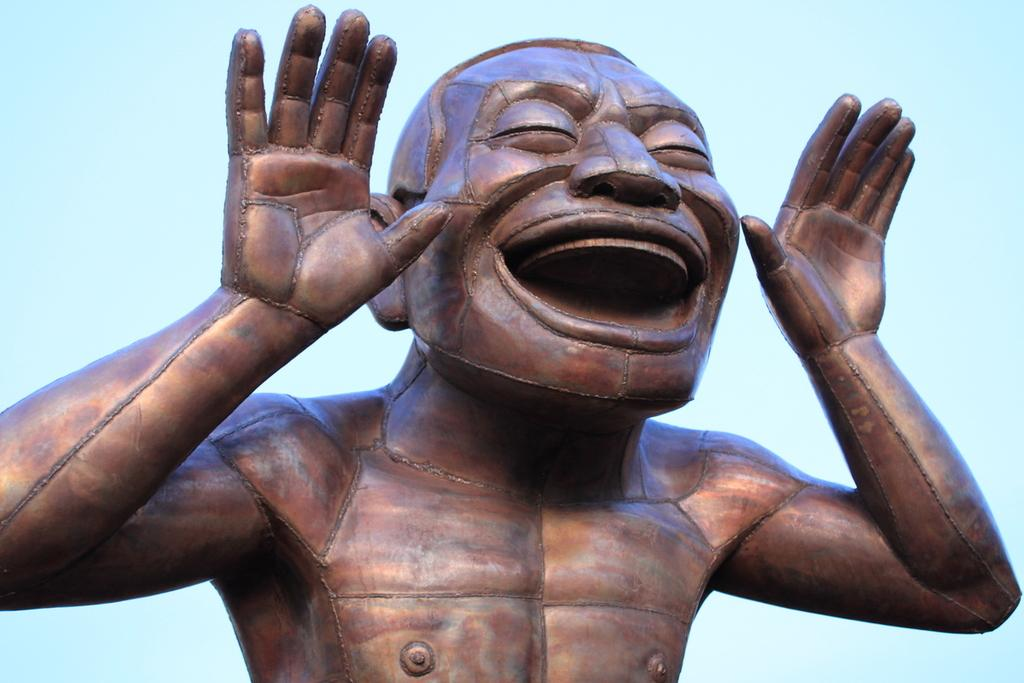What is the main subject in the center of the image? There is a statue in the center of the image. What color is the statue? The statue is brown in color. What can be seen in the background of the image? There is a sky visible in the background of the image. How many eyes does the statue have in the image? The statue does not have eyes, as it is a non-living object and does not possess human-like features. 